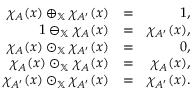<formula> <loc_0><loc_0><loc_500><loc_500>\begin{array} { r l r } { \chi _ { A } ( x ) \oplus _ { \mathbb { X } } \chi _ { A ^ { \prime } } ( x ) } & { = } & { 1 , } \\ { 1 \ominus _ { \mathbb { X } } \chi _ { A } ( x ) } & { = } & { \chi _ { A ^ { \prime } } ( x ) , } \\ { \chi _ { A } ( x ) \odot _ { \mathbb { X } } \chi _ { A ^ { \prime } } ( x ) } & { = } & { 0 , } \\ { \chi _ { A } ( x ) \odot _ { \mathbb { X } } \chi _ { A } ( x ) } & { = } & { \chi _ { A } ( x ) , } \\ { \chi _ { A ^ { \prime } } ( x ) \odot _ { \mathbb { X } } \chi _ { A ^ { \prime } } ( x ) } & { = } & { \chi _ { A ^ { \prime } } ( x ) . } \end{array}</formula> 